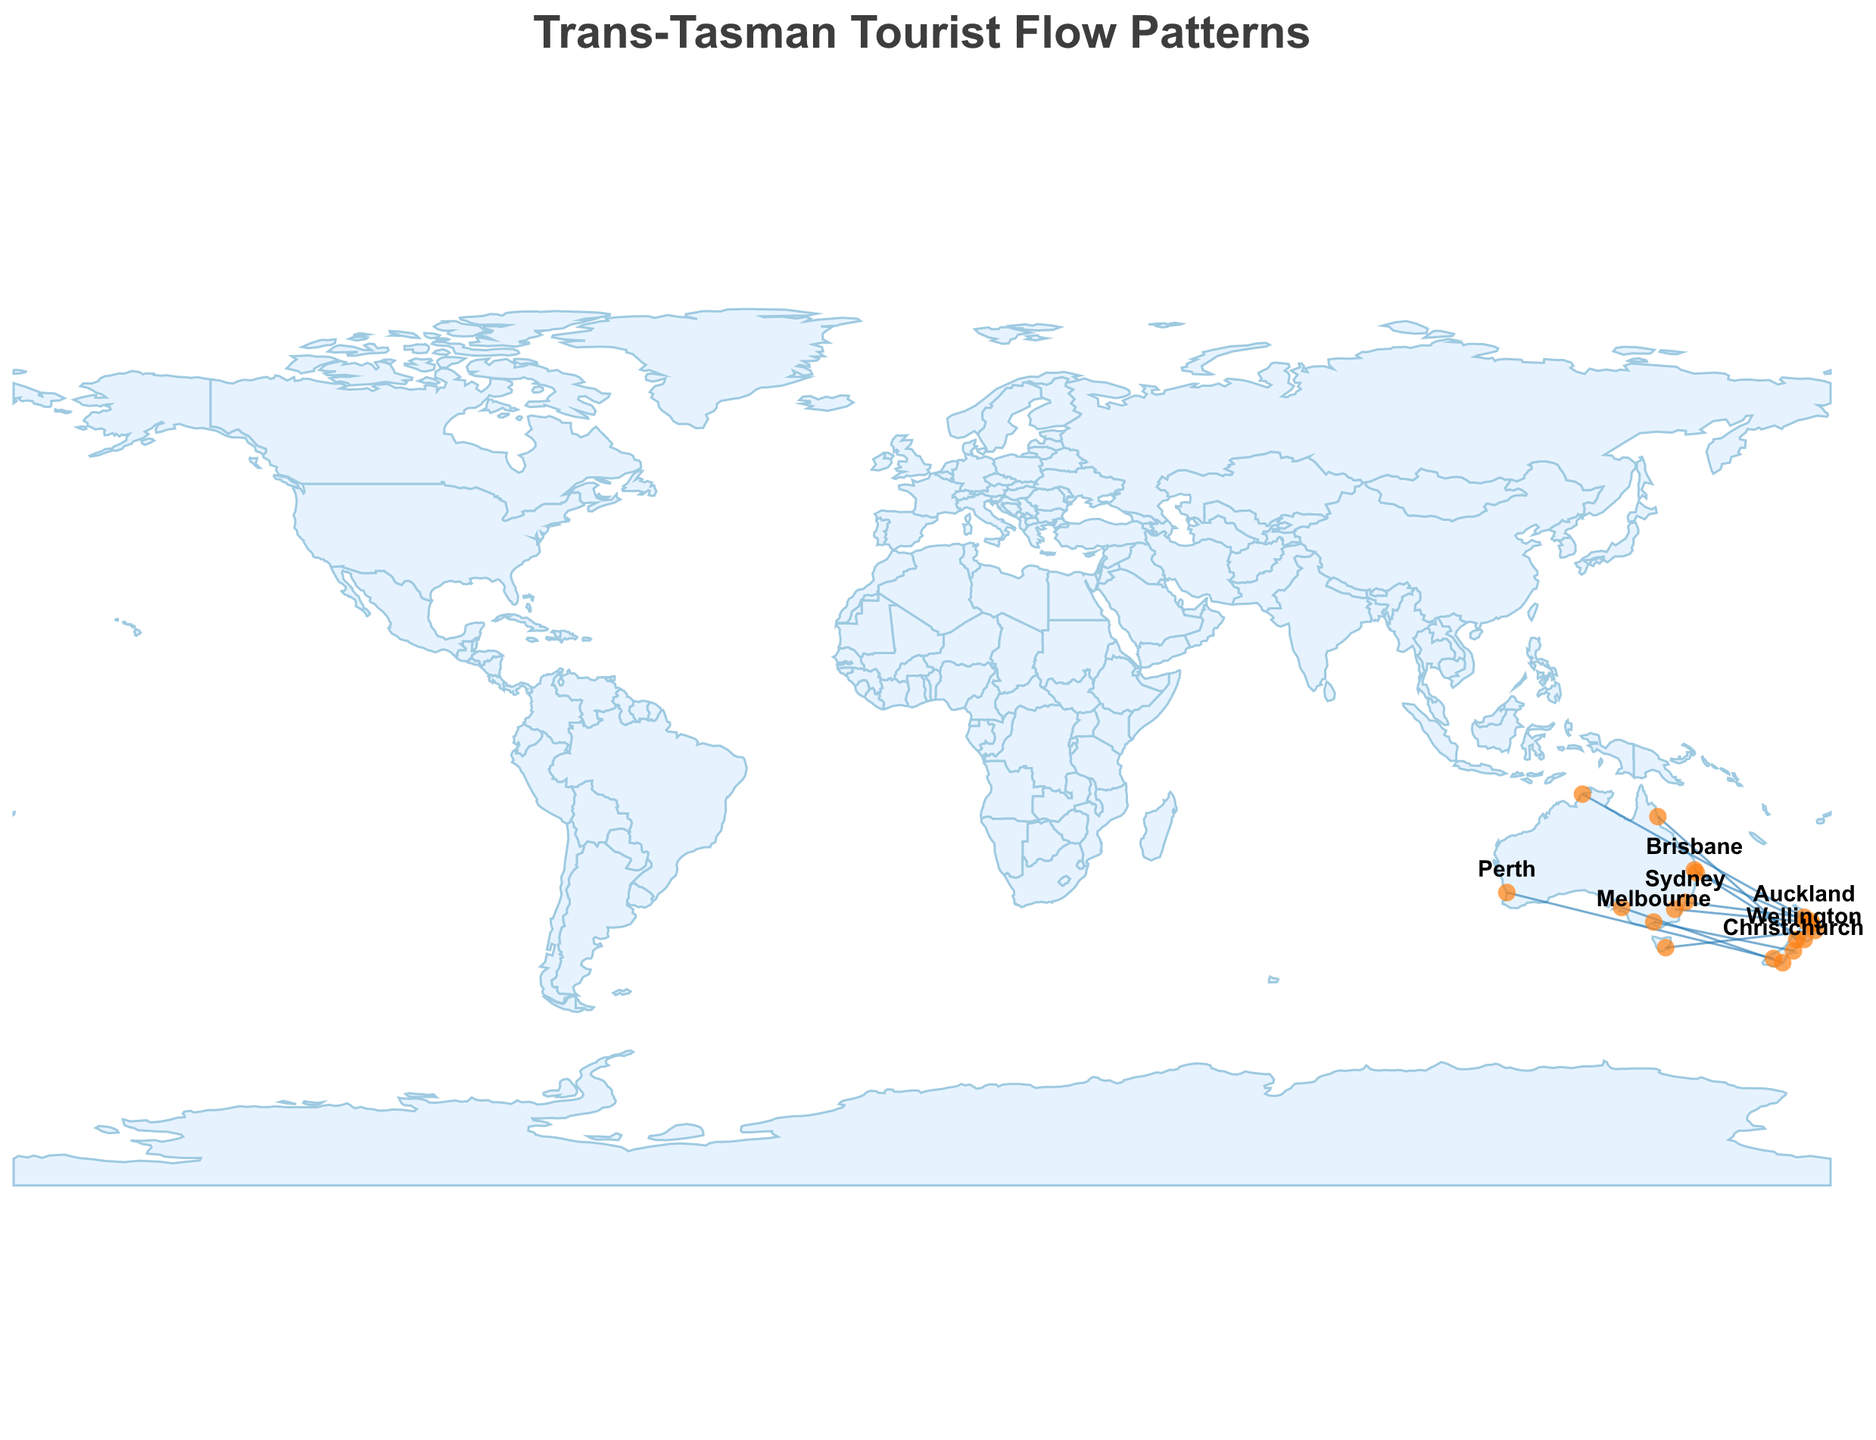what is the title of the figure? The title is clearly displayed at the top of the figure.
Answer: Trans-Tasman Tourist Flow Patterns Which origin city has the highest annual passenger flow to a destination? The city with the thickest line starting from it indicates the highest flow of passengers.
Answer: Sydney What is the most popular reason for travel from Perth to Queenstown? The reasons for travel are indicated in the tooltip when hovering over the origin and destination cities.
Answer: Ski Tourism What is the approximate annual passenger flow from Brisbane to Wellington? By looking at the thickness of the line between Brisbane and Wellington and hovering over it, the tooltip reveals the number.
Answer: 600,000 Which route has adventure tourism as the popular reason? The tooltip shown when hovering over lines between cities reveals this information for each route.
Answer: Gold Coast to Rotorua What is the combined annual passenger flow for routes from Melbourne and Sydney? Adding the passenger counts from Melbourne to Christchurch (800,000) and Sydney to Auckland (1,200,000) gives the total.
Answer: 2,000,000 Which city pair is associated with Government Relations as the main travel reason? The tooltip text when hovering over lines between origin and destination cities will show this.
Answer: Canberra to Hamilton Compare the passenger flows from Melbourne to Christchurch and Adelaide to Dunedin. Which is higher? Checking the thickness of the lines and confirming with the tooltip reveals that Melbourne to Christchurch has higher passenger flow.
Answer: Melbourne to Christchurch What does the color of the lines in the plot represent? The plot uses a uniform color for lines, which indicates the shared characteristic of tourist flows between the cities.
Answer: Tourist flow routes What are some of the key visual elements used to indicate passenger flow magnitude? The thickness of the lines is used to visually represent the magnitude of passenger flow between cities.
Answer: Line thickness 